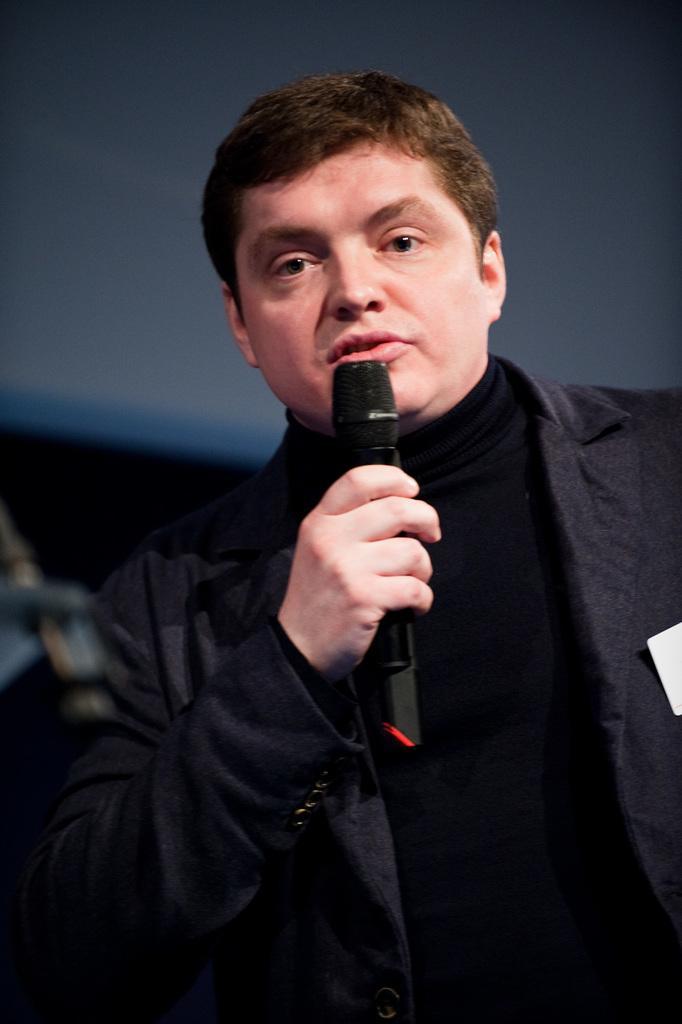Describe this image in one or two sentences. This picture is mainly highlighted wearing a black colour shirt and a black blazer over it. Standing and holding a mike in his hand and talking. Background is blurry. 